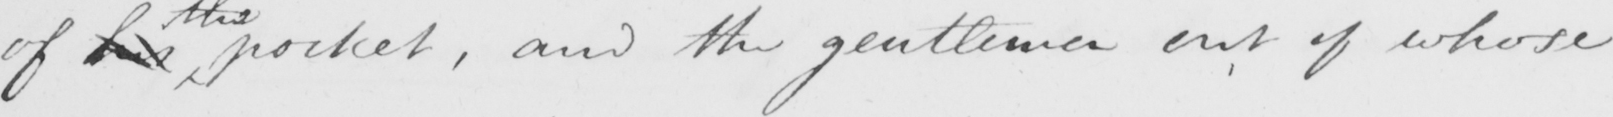What is written in this line of handwriting? of his pocket , and the gentlemen out of whose 